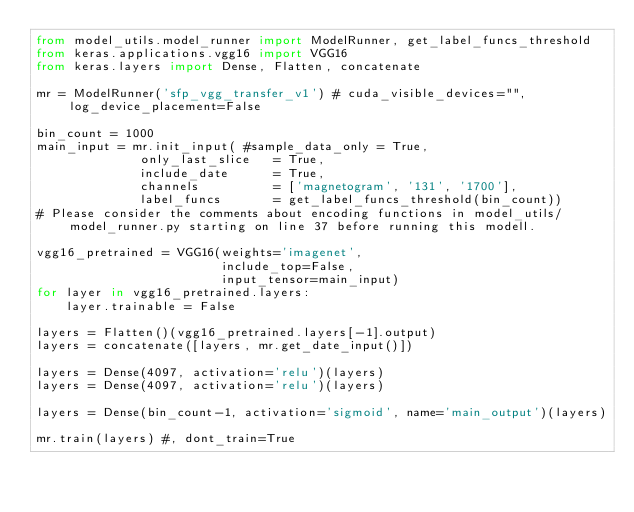Convert code to text. <code><loc_0><loc_0><loc_500><loc_500><_Python_>from model_utils.model_runner import ModelRunner, get_label_funcs_threshold
from keras.applications.vgg16 import VGG16
from keras.layers import Dense, Flatten, concatenate

mr = ModelRunner('sfp_vgg_transfer_v1') # cuda_visible_devices="", log_device_placement=False

bin_count = 1000
main_input = mr.init_input( #sample_data_only = True,
              only_last_slice   = True,
              include_date      = True,
              channels          = ['magnetogram', '131', '1700'],
              label_funcs       = get_label_funcs_threshold(bin_count))
# Please consider the comments about encoding functions in model_utils/model_runner.py starting on line 37 before running this modell.

vgg16_pretrained = VGG16(weights='imagenet',
                         include_top=False,
                         input_tensor=main_input)
for layer in vgg16_pretrained.layers:
    layer.trainable = False

layers = Flatten()(vgg16_pretrained.layers[-1].output)
layers = concatenate([layers, mr.get_date_input()])

layers = Dense(4097, activation='relu')(layers)
layers = Dense(4097, activation='relu')(layers)

layers = Dense(bin_count-1, activation='sigmoid', name='main_output')(layers)

mr.train(layers) #, dont_train=True
</code> 